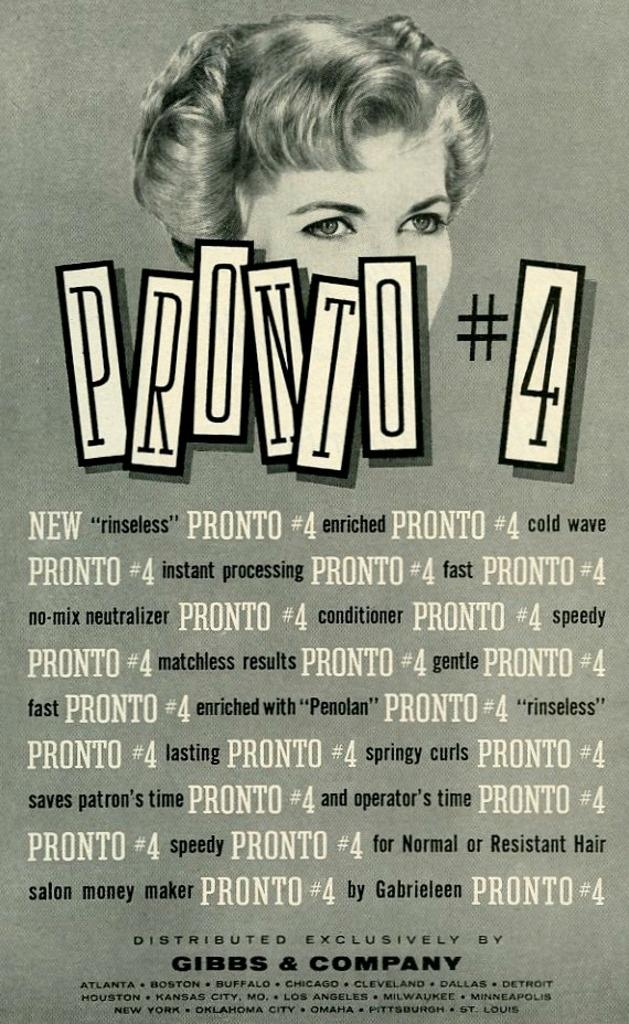<image>
Share a concise interpretation of the image provided. An old ad for Pronto #4 in black and white. 